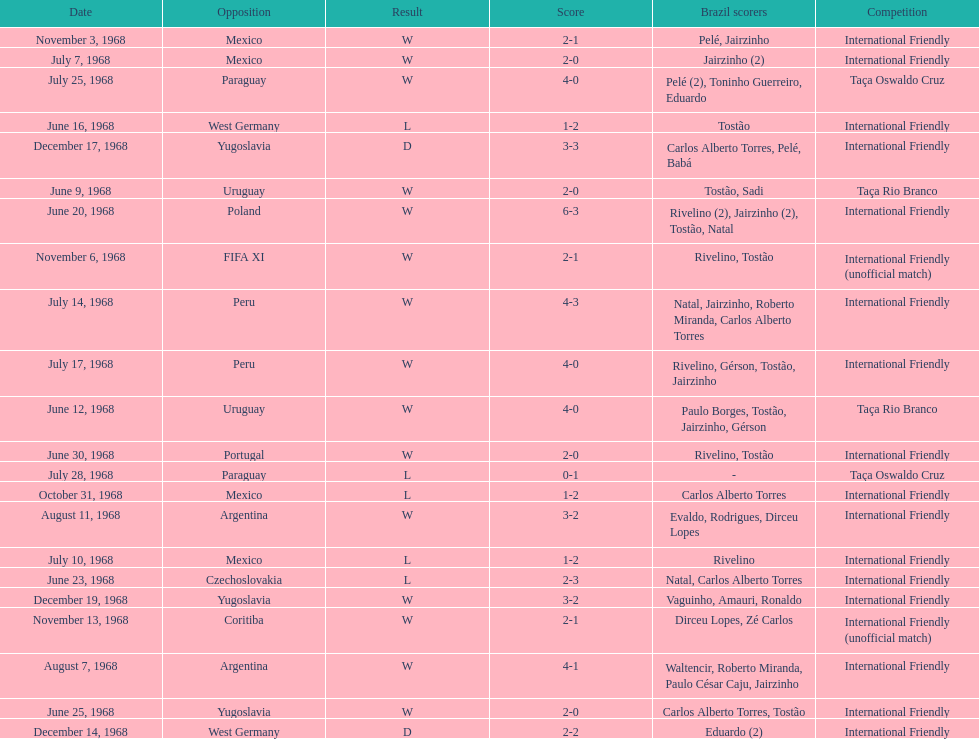What is the number of countries they have played? 11. 